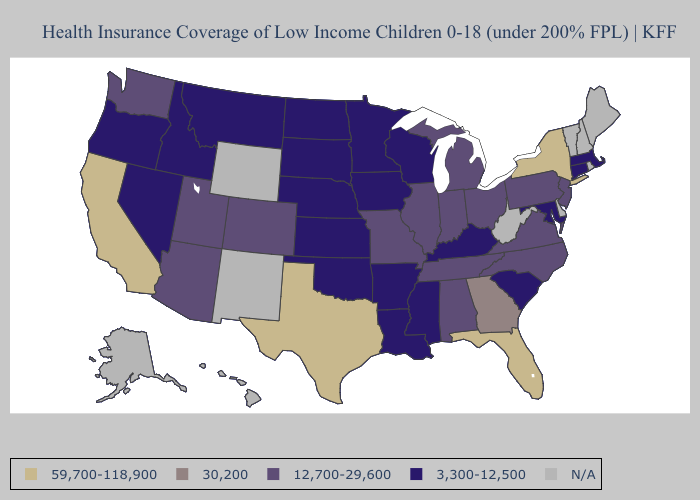What is the value of Minnesota?
Write a very short answer. 3,300-12,500. Does Nevada have the lowest value in the West?
Quick response, please. Yes. What is the value of Indiana?
Concise answer only. 12,700-29,600. Which states have the lowest value in the USA?
Write a very short answer. Arkansas, Connecticut, Idaho, Iowa, Kansas, Kentucky, Louisiana, Maryland, Massachusetts, Minnesota, Mississippi, Montana, Nebraska, Nevada, North Dakota, Oklahoma, Oregon, South Carolina, South Dakota, Wisconsin. What is the value of Rhode Island?
Write a very short answer. N/A. Name the states that have a value in the range 3,300-12,500?
Keep it brief. Arkansas, Connecticut, Idaho, Iowa, Kansas, Kentucky, Louisiana, Maryland, Massachusetts, Minnesota, Mississippi, Montana, Nebraska, Nevada, North Dakota, Oklahoma, Oregon, South Carolina, South Dakota, Wisconsin. Name the states that have a value in the range N/A?
Write a very short answer. Alaska, Delaware, Hawaii, Maine, New Hampshire, New Mexico, Rhode Island, Vermont, West Virginia, Wyoming. Does New York have the highest value in the Northeast?
Short answer required. Yes. Which states have the lowest value in the Northeast?
Keep it brief. Connecticut, Massachusetts. Does Oregon have the lowest value in the West?
Short answer required. Yes. What is the value of Colorado?
Concise answer only. 12,700-29,600. Which states have the lowest value in the Northeast?
Quick response, please. Connecticut, Massachusetts. 